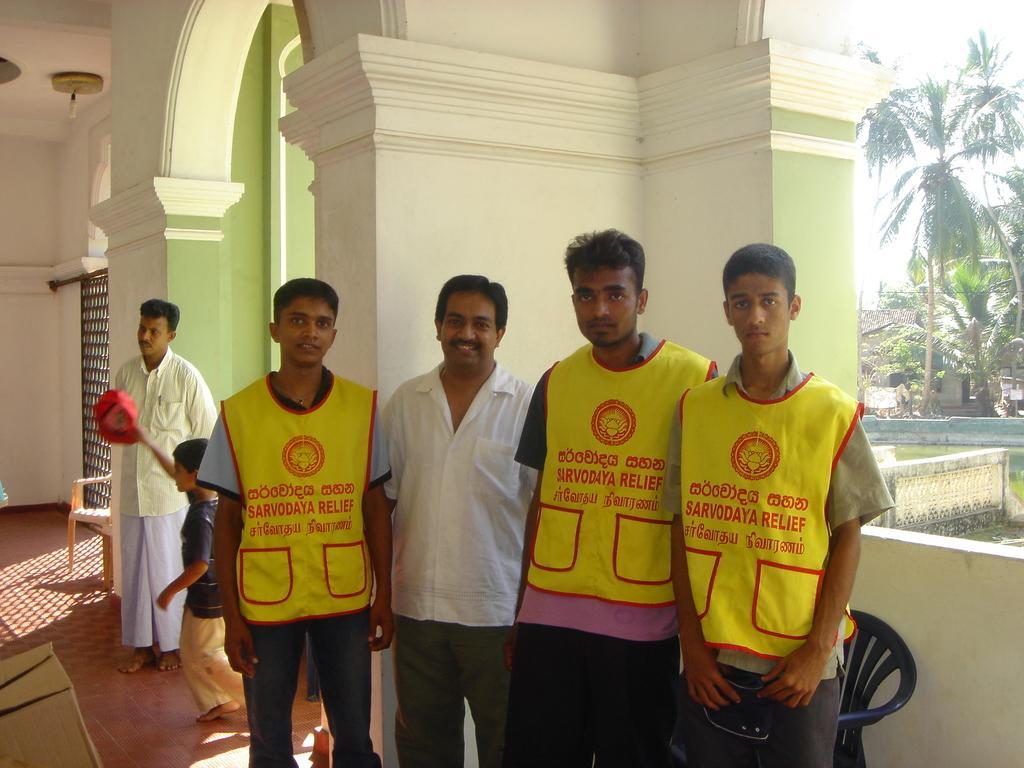Can you describe this image briefly? In the picture we can see a building inside it, we can see a huge pillar and some men are standing near it and they are with yellow color jackets on it, we can see as Sarvodaya relief and in the background we can see trees outside the building. 